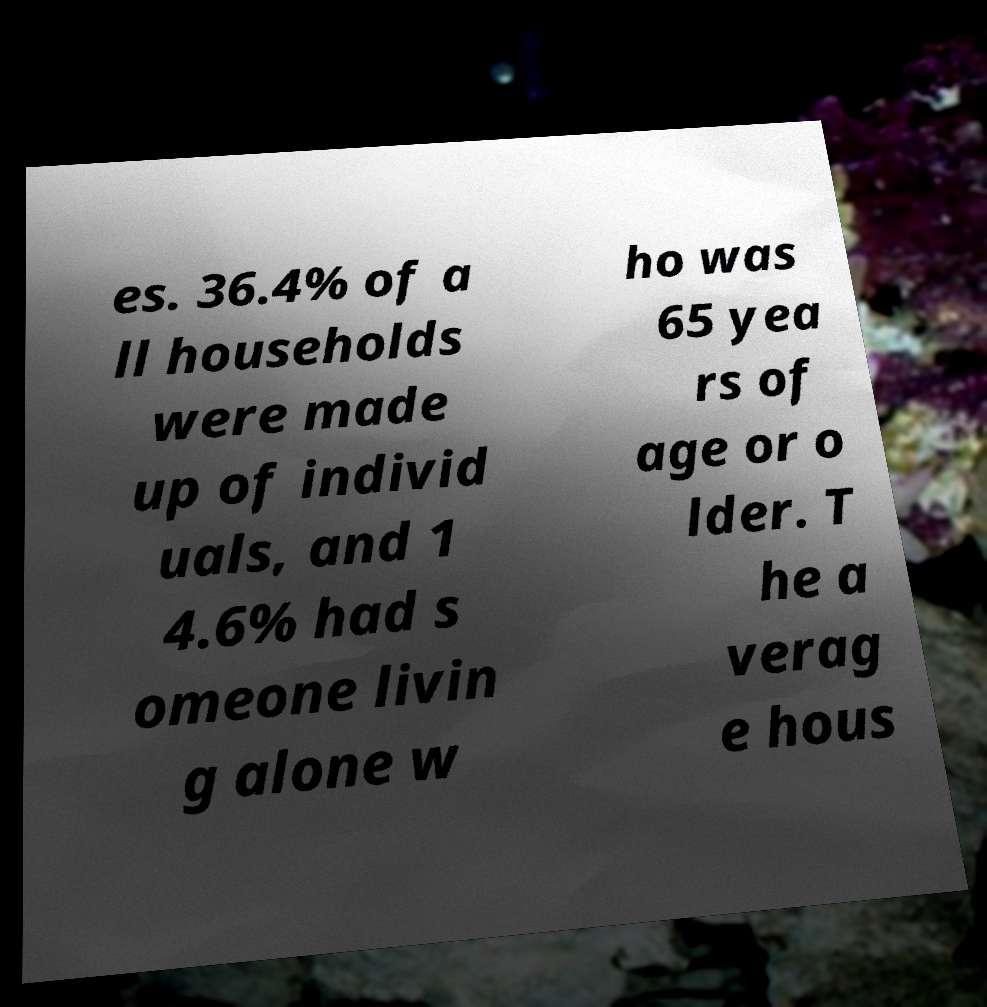What messages or text are displayed in this image? I need them in a readable, typed format. es. 36.4% of a ll households were made up of individ uals, and 1 4.6% had s omeone livin g alone w ho was 65 yea rs of age or o lder. T he a verag e hous 